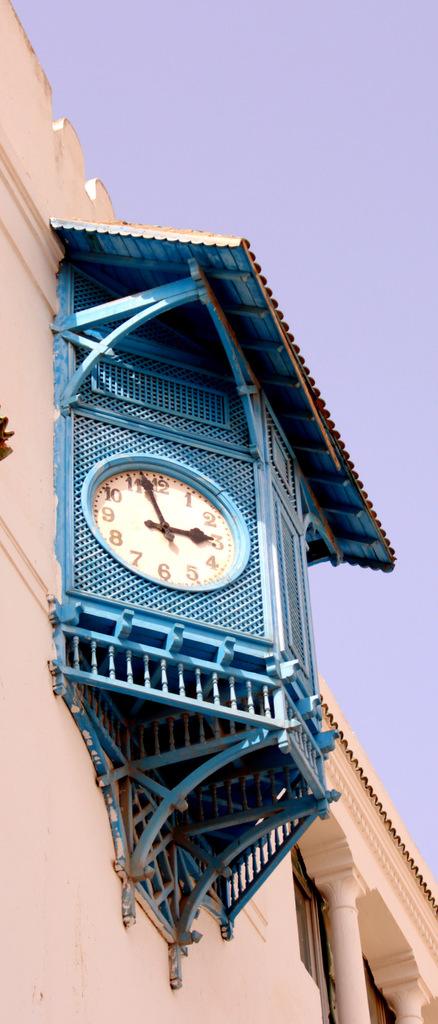Is it 3 o'clock?
Your answer should be compact. No. About what time is it?
Make the answer very short. 3:00. 